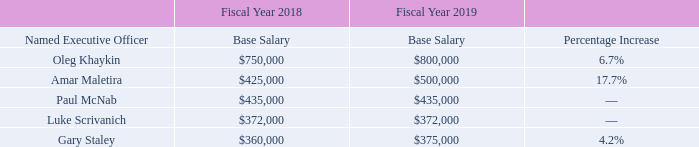Base Salary. The base salary for each NEO is determined on the basis of the following factors: scope of responsibilities, experience, skills, performance, expected future contribution, base salary levels in effect for comparable positions at the companies in the Peer Group (as described on page 42 below under “Use of Peer Group Compensation Data”) and other competitive market factors. Generally, the Committee reviews the base salary levels of our NEOs annually as part of the Company’s performance review process as well as upon a promotion or other change of position or level of responsibility. Merit-based increases to the base salaries of our NEOs (other than our CEO) are recommended by our CEO to the Committee, and all increases are based on the Committee’s (and in the case of our CEO, the Board’s) review and assessment of the factors described above.
The Compensation Committee reviews compensation levels at the beginning of each fiscal year and adjusts as needed based upon market data and executive achievement. The Committee reviewed the base salaries of our executive officers, including our NEOs, for fiscal year 2019 and increased the salaries of our CEO and CFO in light of their contributions in fiscal year 2018, including, among other considerations, the successful execution and integration of the AvComm and Wireless acquisition and to reflect the Committee’s review of current peer and market compensation data. Mr. Staley’s salary was also increased to reflect the Committee’s review of current peer and market compensation data as well as his contributions in fiscal year 2019, including the integration of AvComm and Wireless sales into our global sales organization. The Committee did not increase the salaries of any of our other NEOs because the Committee determined that the existing base salaries were appropriate for each of these NEOs.
Actual base salaries paid to our NEOs in fiscal year 2019 are set forth in the “Salary” column of the Fiscal 2019 Summary Compensation Table on page 44.
When does the Compensation Committee review compensation levels? At the beginning of each fiscal year. What was Oleg Khaykin's base salary in 2018? $750,000. What was Gary Staley's base salary in 2018? $360,000. What was the total base salary of all Named Executive Officers in 2018? ($750,000+$425,000+$435,000+$372,000+$360,000)
Answer: 2342000. How much do the top 3 base salaries in 2019 add up to? ($800,000+$500,000+$435,000)
Answer: 1735000. What is the difference in base salary between Paul McNab and Luke Scrivanch in 2018? ($435,000-$372,000)
Answer: 63000. 